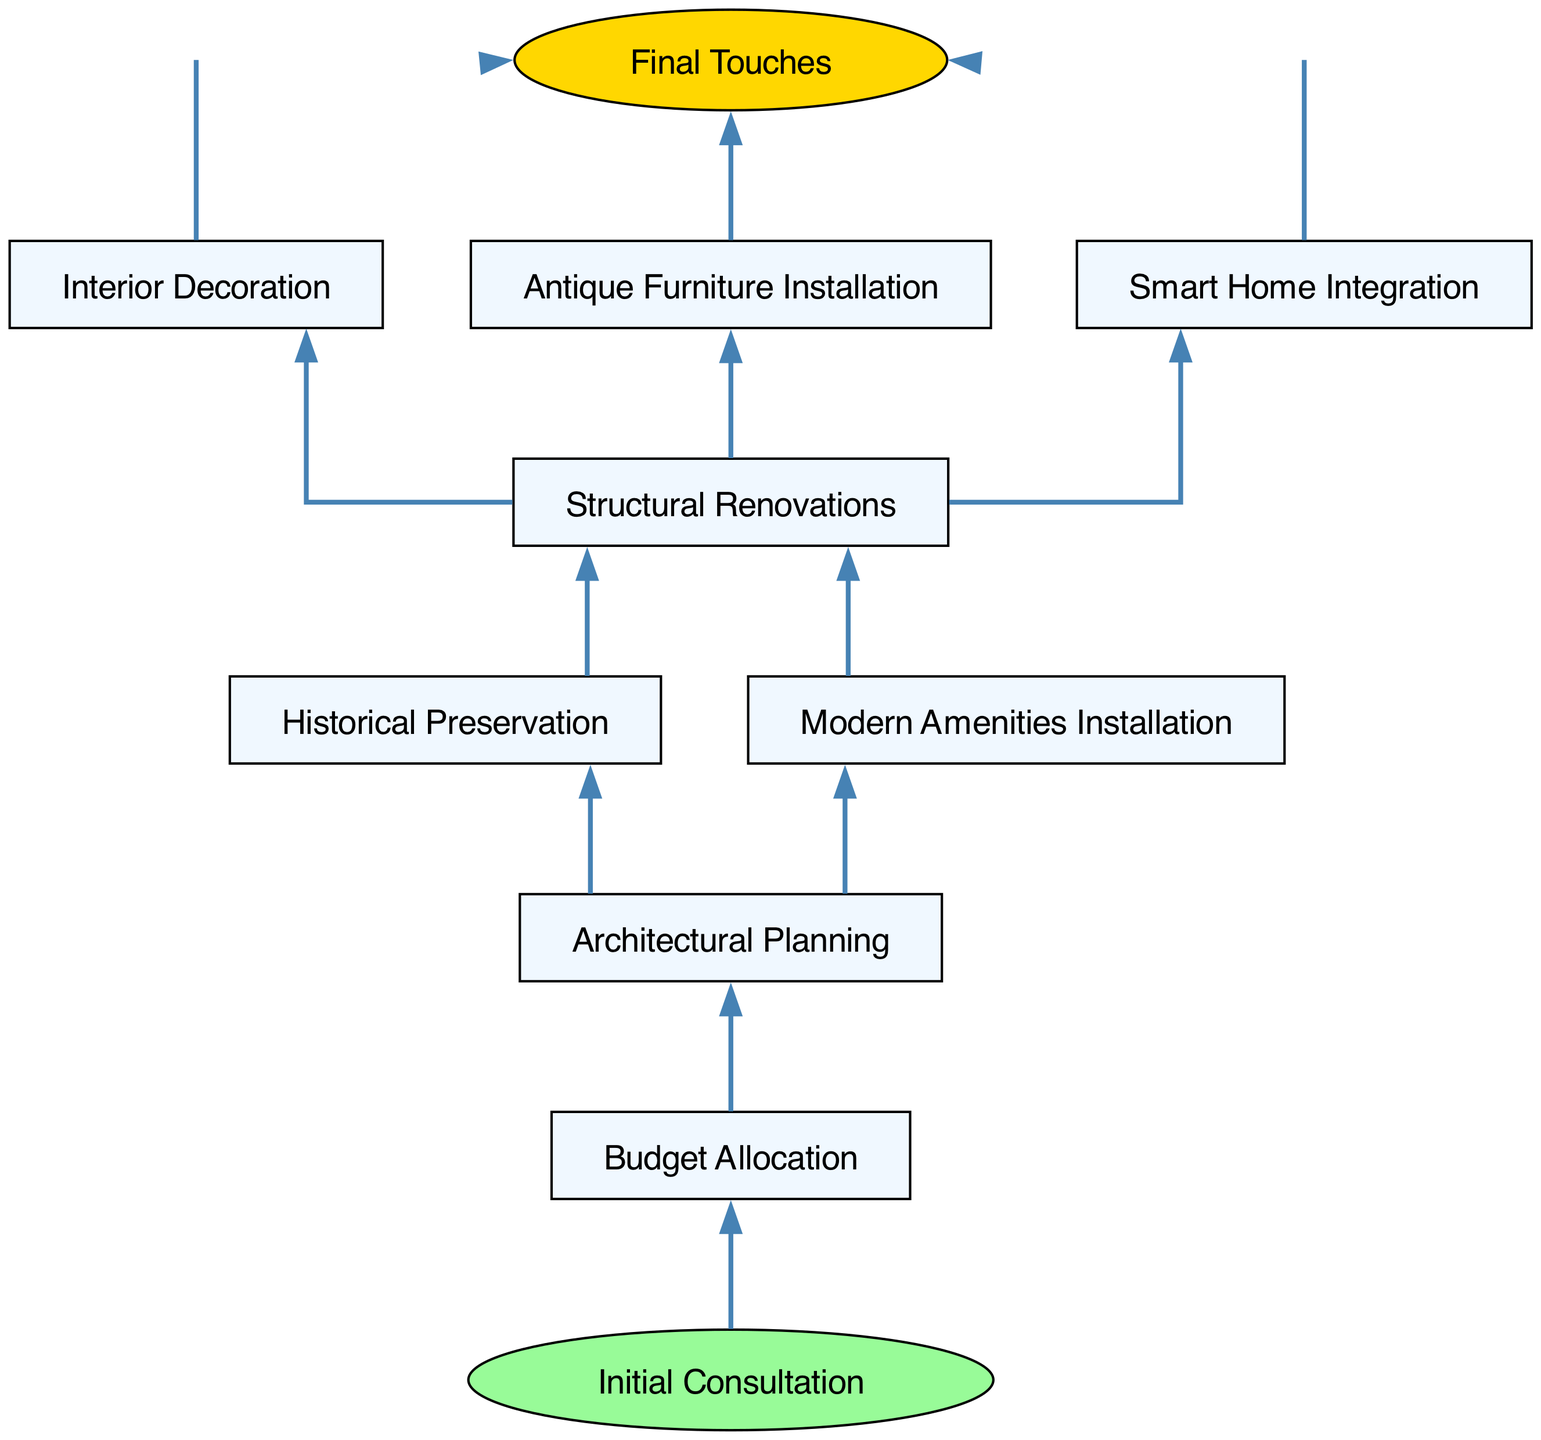What is the final step in the renovation project timeline? The diagram indicates that the final step is labeled "Final Touches," which is the last node in the flow chart.
Answer: Final Touches How many nodes are in the diagram? By counting the distinct nodes listed in the diagram, there are 10 nodes representing various stages of the renovation project.
Answer: 10 What comes before "Interior Decoration"? The directed edge from "Structural Renovations" to "Interior Decoration" indicates that "Structural Renovations" occurs before "Interior Decoration."
Answer: Structural Renovations Which step follows "Budget Allocation"? The diagram shows a directed connection from "Budget Allocation" to "Architectural Planning," indicating that "Architectural Planning" follows after "Budget Allocation."
Answer: Architectural Planning How many edges connect to "Final Touches"? Examining the diagram, "Final Touches" has three incoming edges, therefore, three distinct activities direct towards it.
Answer: 3 Which nodes directly influence "Structural Renovations"? The flow chart illustrates that "Historical Preservation" and "Modern Amenities Installation" direct towards "Structural Renovations," indicating they are prerequisites for that stage.
Answer: Historical Preservation, Modern Amenities Installation What are the prerequisite steps before reaching "Interior Decoration"? The path to "Interior Decoration" starts from "Budget Allocation," flows to "Architectural Planning," and finally goes through "Structural Renovations" before reaching "Interior Decoration."
Answer: Budget Allocation, Architectural Planning, Structural Renovations What is the first step indicated in the renovation project timeline? The diagram clearly identifies "Initial Consultation" as the starting point of the project timeline, connecting to "Budget Allocation."
Answer: Initial Consultation 